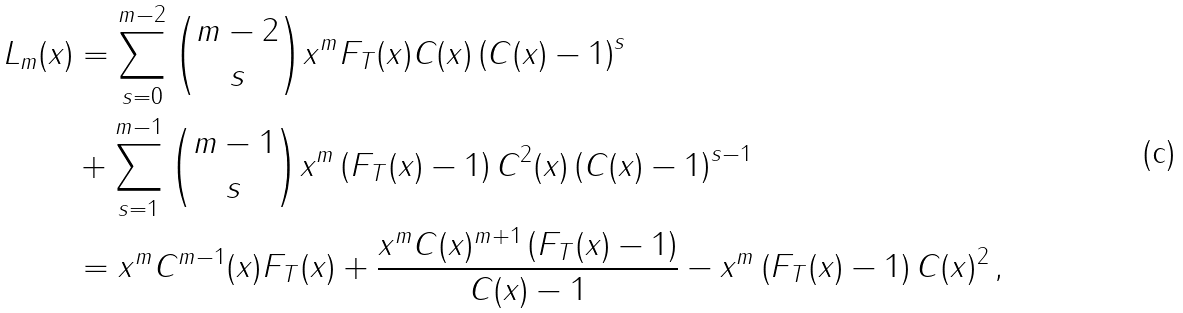Convert formula to latex. <formula><loc_0><loc_0><loc_500><loc_500>L _ { m } ( x ) & = \sum _ { s = 0 } ^ { m - 2 } \binom { m - 2 } { s } x ^ { m } F _ { T } ( x ) C ( x ) \left ( C ( x ) - 1 \right ) ^ { s } \\ & + \sum _ { s = 1 } ^ { m - 1 } \binom { m - 1 } { s } x ^ { m } \left ( F _ { T } ( x ) - 1 \right ) C ^ { 2 } ( x ) \left ( C ( x ) - 1 \right ) ^ { s - 1 } \\ & = x ^ { m } C ^ { m - 1 } ( x ) F _ { T } ( x ) + \frac { x ^ { m } C ( x ) ^ { m + 1 } \left ( F _ { T } ( x ) - 1 \right ) } { C ( x ) - 1 } - x ^ { m } \left ( F _ { T } ( x ) - 1 \right ) C ( x ) ^ { 2 } \, ,</formula> 